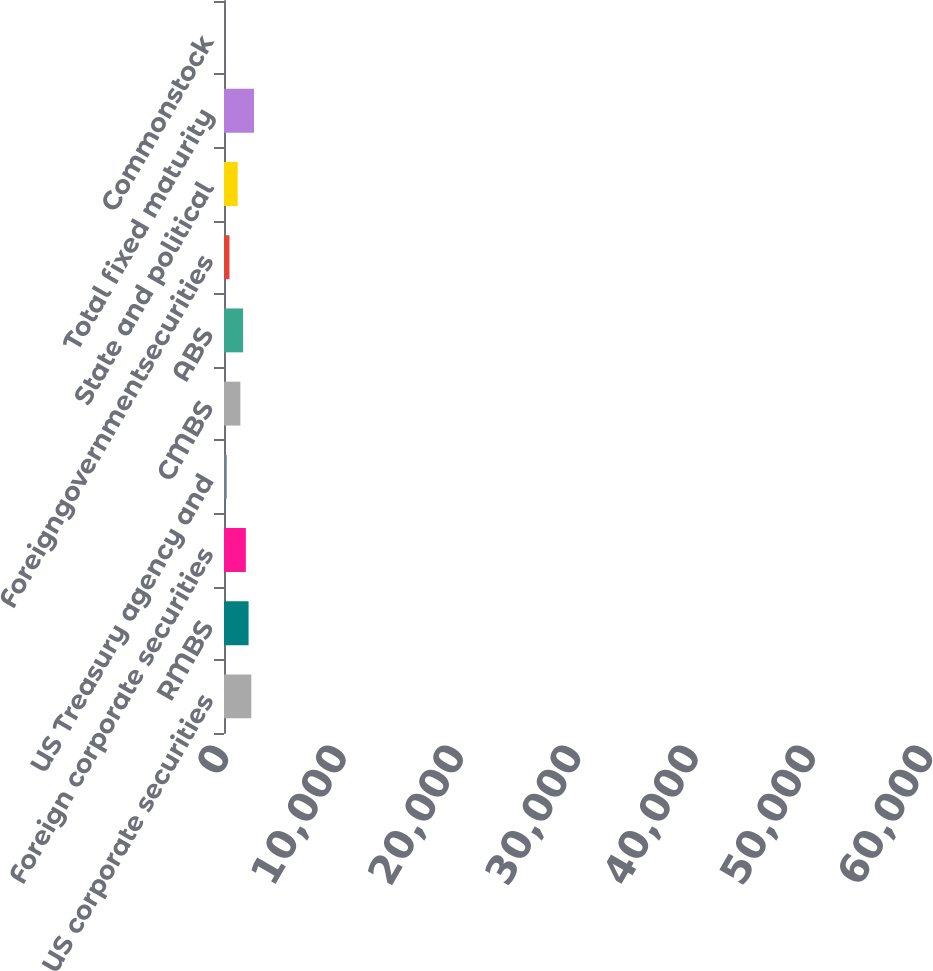<chart> <loc_0><loc_0><loc_500><loc_500><bar_chart><fcel>US corporate securities<fcel>RMBS<fcel>Foreign corporate securities<fcel>US Treasury agency and<fcel>CMBS<fcel>ABS<fcel>Foreigngovernmentsecurities<fcel>State and political<fcel>Total fixed maturity<fcel>Commonstock<nl><fcel>49265<fcel>44339.9<fcel>39414.8<fcel>4939.1<fcel>29564.6<fcel>34489.7<fcel>9864.2<fcel>24639.5<fcel>54190.1<fcel>14<nl></chart> 